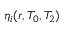<formula> <loc_0><loc_0><loc_500><loc_500>\eta _ { i } ( r , T _ { 0 } , T _ { 2 } )</formula> 